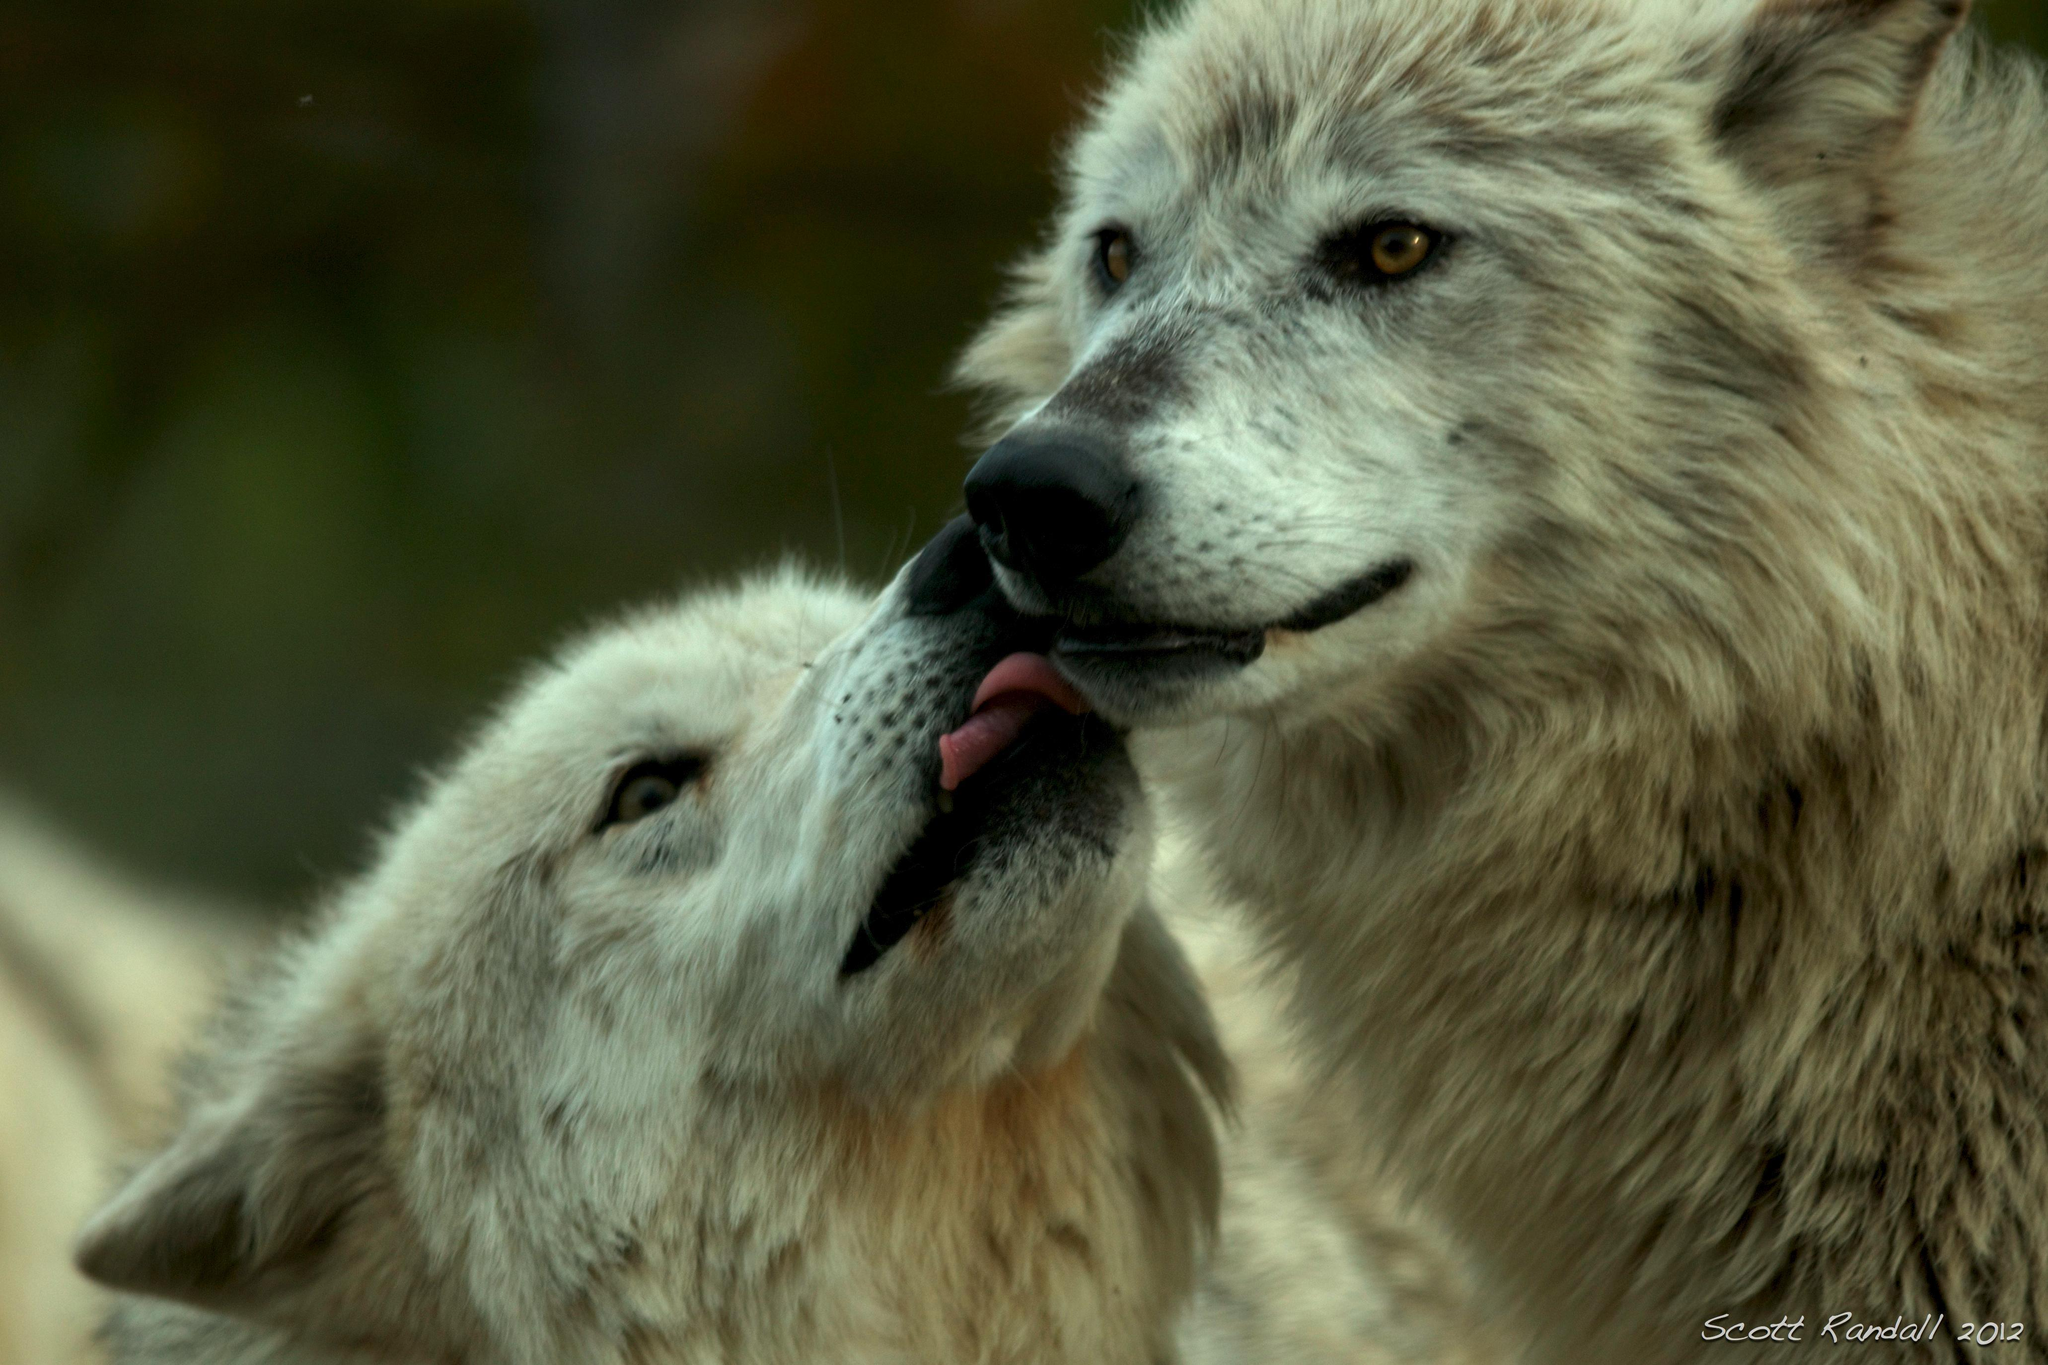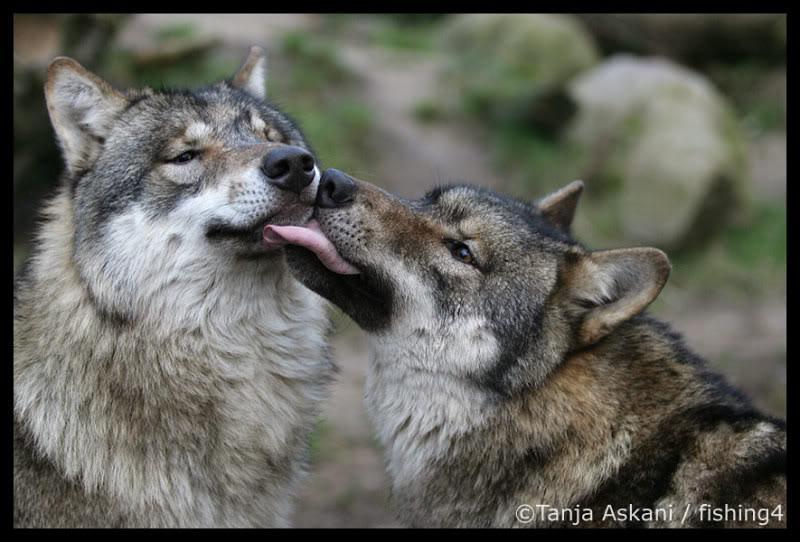The first image is the image on the left, the second image is the image on the right. Considering the images on both sides, is "You can see a wolf's tongue." valid? Answer yes or no. Yes. The first image is the image on the left, the second image is the image on the right. Examine the images to the left and right. Is the description "At least one wolf is using their tongue to kiss." accurate? Answer yes or no. Yes. 